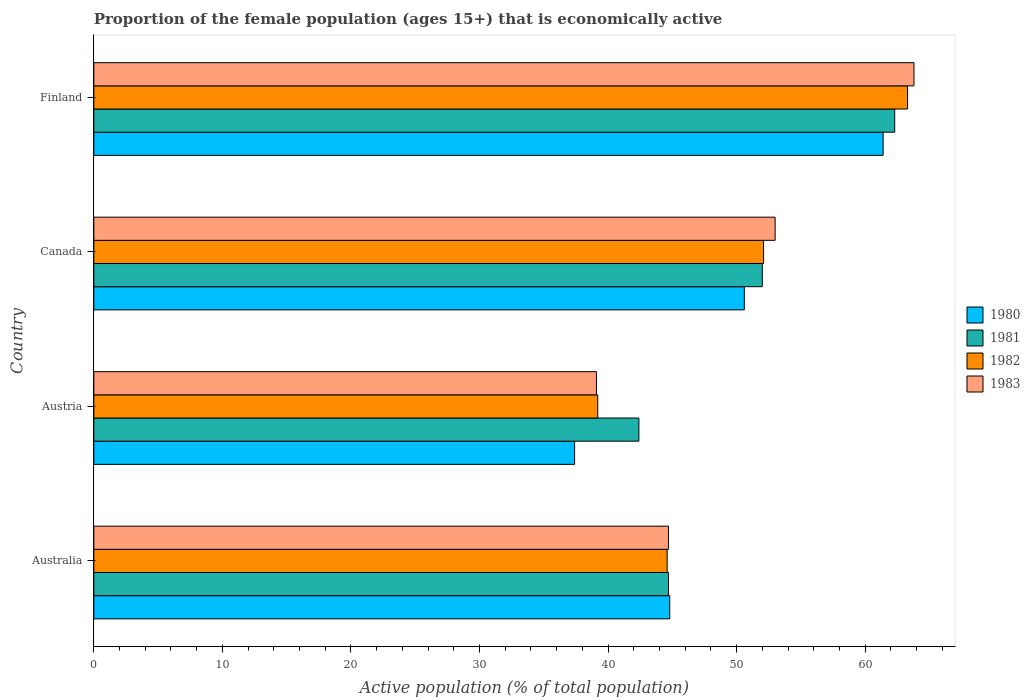How many different coloured bars are there?
Your response must be concise. 4. How many bars are there on the 4th tick from the top?
Offer a very short reply. 4. How many bars are there on the 4th tick from the bottom?
Give a very brief answer. 4. What is the label of the 1st group of bars from the top?
Offer a terse response. Finland. What is the proportion of the female population that is economically active in 1981 in Austria?
Ensure brevity in your answer.  42.4. Across all countries, what is the maximum proportion of the female population that is economically active in 1982?
Your response must be concise. 63.3. Across all countries, what is the minimum proportion of the female population that is economically active in 1982?
Keep it short and to the point. 39.2. In which country was the proportion of the female population that is economically active in 1980 maximum?
Keep it short and to the point. Finland. In which country was the proportion of the female population that is economically active in 1982 minimum?
Provide a succinct answer. Austria. What is the total proportion of the female population that is economically active in 1980 in the graph?
Your answer should be compact. 194.2. What is the difference between the proportion of the female population that is economically active in 1982 in Australia and that in Finland?
Your answer should be very brief. -18.7. What is the difference between the proportion of the female population that is economically active in 1982 in Austria and the proportion of the female population that is economically active in 1983 in Finland?
Provide a succinct answer. -24.6. What is the average proportion of the female population that is economically active in 1981 per country?
Offer a terse response. 50.35. What is the difference between the proportion of the female population that is economically active in 1980 and proportion of the female population that is economically active in 1981 in Finland?
Your answer should be very brief. -0.9. In how many countries, is the proportion of the female population that is economically active in 1983 greater than 10 %?
Give a very brief answer. 4. What is the ratio of the proportion of the female population that is economically active in 1982 in Austria to that in Finland?
Make the answer very short. 0.62. Is the proportion of the female population that is economically active in 1983 in Australia less than that in Finland?
Your response must be concise. Yes. Is the difference between the proportion of the female population that is economically active in 1980 in Austria and Canada greater than the difference between the proportion of the female population that is economically active in 1981 in Austria and Canada?
Offer a very short reply. No. What is the difference between the highest and the second highest proportion of the female population that is economically active in 1982?
Provide a short and direct response. 11.2. What is the difference between the highest and the lowest proportion of the female population that is economically active in 1982?
Provide a short and direct response. 24.1. In how many countries, is the proportion of the female population that is economically active in 1980 greater than the average proportion of the female population that is economically active in 1980 taken over all countries?
Your response must be concise. 2. Is the sum of the proportion of the female population that is economically active in 1982 in Austria and Canada greater than the maximum proportion of the female population that is economically active in 1983 across all countries?
Your response must be concise. Yes. What does the 1st bar from the top in Finland represents?
Ensure brevity in your answer.  1983. How many countries are there in the graph?
Make the answer very short. 4. What is the difference between two consecutive major ticks on the X-axis?
Your answer should be compact. 10. Are the values on the major ticks of X-axis written in scientific E-notation?
Provide a short and direct response. No. Does the graph contain grids?
Offer a very short reply. No. How are the legend labels stacked?
Provide a succinct answer. Vertical. What is the title of the graph?
Offer a very short reply. Proportion of the female population (ages 15+) that is economically active. Does "1987" appear as one of the legend labels in the graph?
Make the answer very short. No. What is the label or title of the X-axis?
Keep it short and to the point. Active population (% of total population). What is the label or title of the Y-axis?
Keep it short and to the point. Country. What is the Active population (% of total population) of 1980 in Australia?
Ensure brevity in your answer.  44.8. What is the Active population (% of total population) of 1981 in Australia?
Ensure brevity in your answer.  44.7. What is the Active population (% of total population) of 1982 in Australia?
Give a very brief answer. 44.6. What is the Active population (% of total population) in 1983 in Australia?
Ensure brevity in your answer.  44.7. What is the Active population (% of total population) of 1980 in Austria?
Give a very brief answer. 37.4. What is the Active population (% of total population) in 1981 in Austria?
Your answer should be compact. 42.4. What is the Active population (% of total population) in 1982 in Austria?
Give a very brief answer. 39.2. What is the Active population (% of total population) in 1983 in Austria?
Provide a succinct answer. 39.1. What is the Active population (% of total population) in 1980 in Canada?
Your answer should be compact. 50.6. What is the Active population (% of total population) of 1981 in Canada?
Your answer should be very brief. 52. What is the Active population (% of total population) of 1982 in Canada?
Your response must be concise. 52.1. What is the Active population (% of total population) of 1983 in Canada?
Offer a very short reply. 53. What is the Active population (% of total population) of 1980 in Finland?
Provide a succinct answer. 61.4. What is the Active population (% of total population) in 1981 in Finland?
Provide a succinct answer. 62.3. What is the Active population (% of total population) of 1982 in Finland?
Your answer should be very brief. 63.3. What is the Active population (% of total population) in 1983 in Finland?
Provide a short and direct response. 63.8. Across all countries, what is the maximum Active population (% of total population) in 1980?
Offer a terse response. 61.4. Across all countries, what is the maximum Active population (% of total population) in 1981?
Keep it short and to the point. 62.3. Across all countries, what is the maximum Active population (% of total population) in 1982?
Your answer should be compact. 63.3. Across all countries, what is the maximum Active population (% of total population) in 1983?
Give a very brief answer. 63.8. Across all countries, what is the minimum Active population (% of total population) in 1980?
Your answer should be compact. 37.4. Across all countries, what is the minimum Active population (% of total population) in 1981?
Your answer should be very brief. 42.4. Across all countries, what is the minimum Active population (% of total population) in 1982?
Offer a terse response. 39.2. Across all countries, what is the minimum Active population (% of total population) in 1983?
Offer a terse response. 39.1. What is the total Active population (% of total population) in 1980 in the graph?
Make the answer very short. 194.2. What is the total Active population (% of total population) in 1981 in the graph?
Provide a succinct answer. 201.4. What is the total Active population (% of total population) of 1982 in the graph?
Your response must be concise. 199.2. What is the total Active population (% of total population) in 1983 in the graph?
Your answer should be very brief. 200.6. What is the difference between the Active population (% of total population) of 1980 in Australia and that in Austria?
Make the answer very short. 7.4. What is the difference between the Active population (% of total population) in 1981 in Australia and that in Austria?
Provide a succinct answer. 2.3. What is the difference between the Active population (% of total population) of 1982 in Australia and that in Canada?
Make the answer very short. -7.5. What is the difference between the Active population (% of total population) of 1980 in Australia and that in Finland?
Make the answer very short. -16.6. What is the difference between the Active population (% of total population) in 1981 in Australia and that in Finland?
Offer a very short reply. -17.6. What is the difference between the Active population (% of total population) of 1982 in Australia and that in Finland?
Provide a succinct answer. -18.7. What is the difference between the Active population (% of total population) of 1983 in Australia and that in Finland?
Offer a very short reply. -19.1. What is the difference between the Active population (% of total population) of 1980 in Austria and that in Canada?
Your answer should be very brief. -13.2. What is the difference between the Active population (% of total population) in 1983 in Austria and that in Canada?
Give a very brief answer. -13.9. What is the difference between the Active population (% of total population) of 1981 in Austria and that in Finland?
Provide a short and direct response. -19.9. What is the difference between the Active population (% of total population) in 1982 in Austria and that in Finland?
Offer a very short reply. -24.1. What is the difference between the Active population (% of total population) in 1983 in Austria and that in Finland?
Keep it short and to the point. -24.7. What is the difference between the Active population (% of total population) in 1980 in Australia and the Active population (% of total population) in 1981 in Austria?
Ensure brevity in your answer.  2.4. What is the difference between the Active population (% of total population) in 1980 in Australia and the Active population (% of total population) in 1983 in Austria?
Your answer should be very brief. 5.7. What is the difference between the Active population (% of total population) in 1981 in Australia and the Active population (% of total population) in 1982 in Austria?
Offer a terse response. 5.5. What is the difference between the Active population (% of total population) in 1981 in Australia and the Active population (% of total population) in 1983 in Austria?
Offer a very short reply. 5.6. What is the difference between the Active population (% of total population) in 1982 in Australia and the Active population (% of total population) in 1983 in Austria?
Offer a terse response. 5.5. What is the difference between the Active population (% of total population) in 1981 in Australia and the Active population (% of total population) in 1982 in Canada?
Make the answer very short. -7.4. What is the difference between the Active population (% of total population) in 1981 in Australia and the Active population (% of total population) in 1983 in Canada?
Ensure brevity in your answer.  -8.3. What is the difference between the Active population (% of total population) of 1982 in Australia and the Active population (% of total population) of 1983 in Canada?
Provide a short and direct response. -8.4. What is the difference between the Active population (% of total population) in 1980 in Australia and the Active population (% of total population) in 1981 in Finland?
Provide a succinct answer. -17.5. What is the difference between the Active population (% of total population) in 1980 in Australia and the Active population (% of total population) in 1982 in Finland?
Offer a terse response. -18.5. What is the difference between the Active population (% of total population) of 1981 in Australia and the Active population (% of total population) of 1982 in Finland?
Make the answer very short. -18.6. What is the difference between the Active population (% of total population) of 1981 in Australia and the Active population (% of total population) of 1983 in Finland?
Offer a terse response. -19.1. What is the difference between the Active population (% of total population) of 1982 in Australia and the Active population (% of total population) of 1983 in Finland?
Offer a very short reply. -19.2. What is the difference between the Active population (% of total population) in 1980 in Austria and the Active population (% of total population) in 1981 in Canada?
Offer a terse response. -14.6. What is the difference between the Active population (% of total population) in 1980 in Austria and the Active population (% of total population) in 1982 in Canada?
Your answer should be very brief. -14.7. What is the difference between the Active population (% of total population) of 1980 in Austria and the Active population (% of total population) of 1983 in Canada?
Offer a terse response. -15.6. What is the difference between the Active population (% of total population) of 1981 in Austria and the Active population (% of total population) of 1982 in Canada?
Ensure brevity in your answer.  -9.7. What is the difference between the Active population (% of total population) in 1981 in Austria and the Active population (% of total population) in 1983 in Canada?
Provide a short and direct response. -10.6. What is the difference between the Active population (% of total population) in 1980 in Austria and the Active population (% of total population) in 1981 in Finland?
Give a very brief answer. -24.9. What is the difference between the Active population (% of total population) of 1980 in Austria and the Active population (% of total population) of 1982 in Finland?
Provide a succinct answer. -25.9. What is the difference between the Active population (% of total population) in 1980 in Austria and the Active population (% of total population) in 1983 in Finland?
Your answer should be compact. -26.4. What is the difference between the Active population (% of total population) in 1981 in Austria and the Active population (% of total population) in 1982 in Finland?
Your answer should be very brief. -20.9. What is the difference between the Active population (% of total population) of 1981 in Austria and the Active population (% of total population) of 1983 in Finland?
Provide a short and direct response. -21.4. What is the difference between the Active population (% of total population) of 1982 in Austria and the Active population (% of total population) of 1983 in Finland?
Provide a succinct answer. -24.6. What is the difference between the Active population (% of total population) of 1980 in Canada and the Active population (% of total population) of 1981 in Finland?
Your answer should be very brief. -11.7. What is the difference between the Active population (% of total population) of 1980 in Canada and the Active population (% of total population) of 1982 in Finland?
Your response must be concise. -12.7. What is the difference between the Active population (% of total population) in 1980 in Canada and the Active population (% of total population) in 1983 in Finland?
Offer a very short reply. -13.2. What is the difference between the Active population (% of total population) in 1981 in Canada and the Active population (% of total population) in 1982 in Finland?
Offer a very short reply. -11.3. What is the difference between the Active population (% of total population) of 1981 in Canada and the Active population (% of total population) of 1983 in Finland?
Provide a short and direct response. -11.8. What is the average Active population (% of total population) of 1980 per country?
Ensure brevity in your answer.  48.55. What is the average Active population (% of total population) in 1981 per country?
Ensure brevity in your answer.  50.35. What is the average Active population (% of total population) in 1982 per country?
Keep it short and to the point. 49.8. What is the average Active population (% of total population) in 1983 per country?
Your answer should be very brief. 50.15. What is the difference between the Active population (% of total population) in 1981 and Active population (% of total population) in 1982 in Australia?
Offer a very short reply. 0.1. What is the difference between the Active population (% of total population) of 1981 and Active population (% of total population) of 1983 in Australia?
Provide a short and direct response. 0. What is the difference between the Active population (% of total population) in 1982 and Active population (% of total population) in 1983 in Australia?
Give a very brief answer. -0.1. What is the difference between the Active population (% of total population) in 1980 and Active population (% of total population) in 1983 in Austria?
Provide a short and direct response. -1.7. What is the difference between the Active population (% of total population) of 1982 and Active population (% of total population) of 1983 in Austria?
Offer a very short reply. 0.1. What is the difference between the Active population (% of total population) of 1980 and Active population (% of total population) of 1981 in Canada?
Ensure brevity in your answer.  -1.4. What is the difference between the Active population (% of total population) in 1981 and Active population (% of total population) in 1982 in Canada?
Give a very brief answer. -0.1. What is the difference between the Active population (% of total population) of 1982 and Active population (% of total population) of 1983 in Canada?
Keep it short and to the point. -0.9. What is the difference between the Active population (% of total population) of 1980 and Active population (% of total population) of 1983 in Finland?
Offer a very short reply. -2.4. What is the difference between the Active population (% of total population) in 1982 and Active population (% of total population) in 1983 in Finland?
Your answer should be very brief. -0.5. What is the ratio of the Active population (% of total population) of 1980 in Australia to that in Austria?
Provide a short and direct response. 1.2. What is the ratio of the Active population (% of total population) in 1981 in Australia to that in Austria?
Your response must be concise. 1.05. What is the ratio of the Active population (% of total population) of 1982 in Australia to that in Austria?
Your answer should be very brief. 1.14. What is the ratio of the Active population (% of total population) in 1983 in Australia to that in Austria?
Ensure brevity in your answer.  1.14. What is the ratio of the Active population (% of total population) in 1980 in Australia to that in Canada?
Ensure brevity in your answer.  0.89. What is the ratio of the Active population (% of total population) in 1981 in Australia to that in Canada?
Ensure brevity in your answer.  0.86. What is the ratio of the Active population (% of total population) of 1982 in Australia to that in Canada?
Your answer should be very brief. 0.86. What is the ratio of the Active population (% of total population) in 1983 in Australia to that in Canada?
Give a very brief answer. 0.84. What is the ratio of the Active population (% of total population) of 1980 in Australia to that in Finland?
Your answer should be very brief. 0.73. What is the ratio of the Active population (% of total population) in 1981 in Australia to that in Finland?
Your answer should be very brief. 0.72. What is the ratio of the Active population (% of total population) in 1982 in Australia to that in Finland?
Ensure brevity in your answer.  0.7. What is the ratio of the Active population (% of total population) of 1983 in Australia to that in Finland?
Ensure brevity in your answer.  0.7. What is the ratio of the Active population (% of total population) of 1980 in Austria to that in Canada?
Offer a very short reply. 0.74. What is the ratio of the Active population (% of total population) of 1981 in Austria to that in Canada?
Keep it short and to the point. 0.82. What is the ratio of the Active population (% of total population) in 1982 in Austria to that in Canada?
Provide a succinct answer. 0.75. What is the ratio of the Active population (% of total population) of 1983 in Austria to that in Canada?
Offer a terse response. 0.74. What is the ratio of the Active population (% of total population) in 1980 in Austria to that in Finland?
Ensure brevity in your answer.  0.61. What is the ratio of the Active population (% of total population) of 1981 in Austria to that in Finland?
Make the answer very short. 0.68. What is the ratio of the Active population (% of total population) of 1982 in Austria to that in Finland?
Offer a terse response. 0.62. What is the ratio of the Active population (% of total population) of 1983 in Austria to that in Finland?
Provide a short and direct response. 0.61. What is the ratio of the Active population (% of total population) of 1980 in Canada to that in Finland?
Make the answer very short. 0.82. What is the ratio of the Active population (% of total population) of 1981 in Canada to that in Finland?
Offer a terse response. 0.83. What is the ratio of the Active population (% of total population) in 1982 in Canada to that in Finland?
Offer a terse response. 0.82. What is the ratio of the Active population (% of total population) of 1983 in Canada to that in Finland?
Offer a terse response. 0.83. What is the difference between the highest and the second highest Active population (% of total population) in 1981?
Your answer should be compact. 10.3. What is the difference between the highest and the second highest Active population (% of total population) of 1982?
Your response must be concise. 11.2. What is the difference between the highest and the lowest Active population (% of total population) in 1980?
Provide a succinct answer. 24. What is the difference between the highest and the lowest Active population (% of total population) of 1982?
Provide a succinct answer. 24.1. What is the difference between the highest and the lowest Active population (% of total population) of 1983?
Keep it short and to the point. 24.7. 